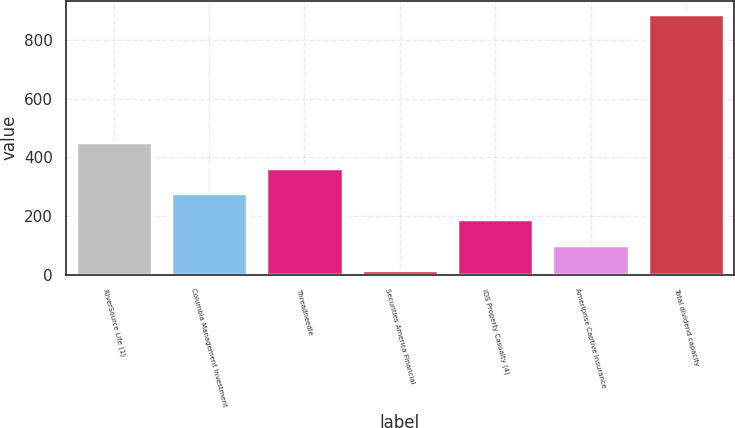Convert chart to OTSL. <chart><loc_0><loc_0><loc_500><loc_500><bar_chart><fcel>RiverSource Life (1)<fcel>Columbia Management Investment<fcel>Threadneedle<fcel>Securities America Financial<fcel>IDS Property Casualty (4)<fcel>Ameriprise Captive Insurance<fcel>Total dividend capacity<nl><fcel>452.5<fcel>277.5<fcel>365<fcel>15<fcel>190<fcel>102.5<fcel>890<nl></chart> 